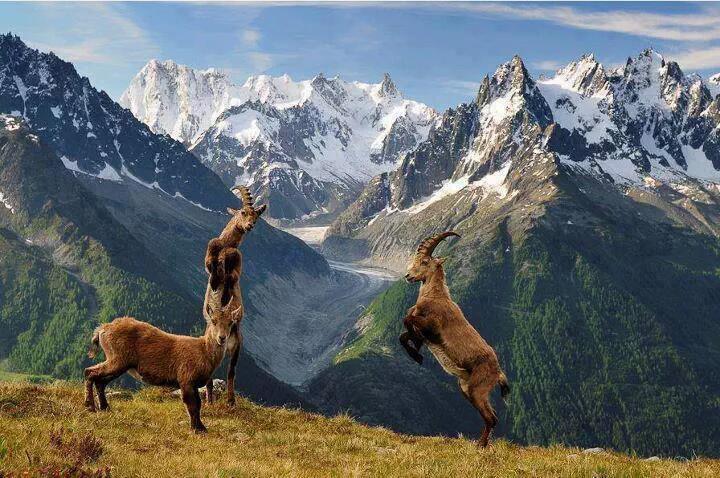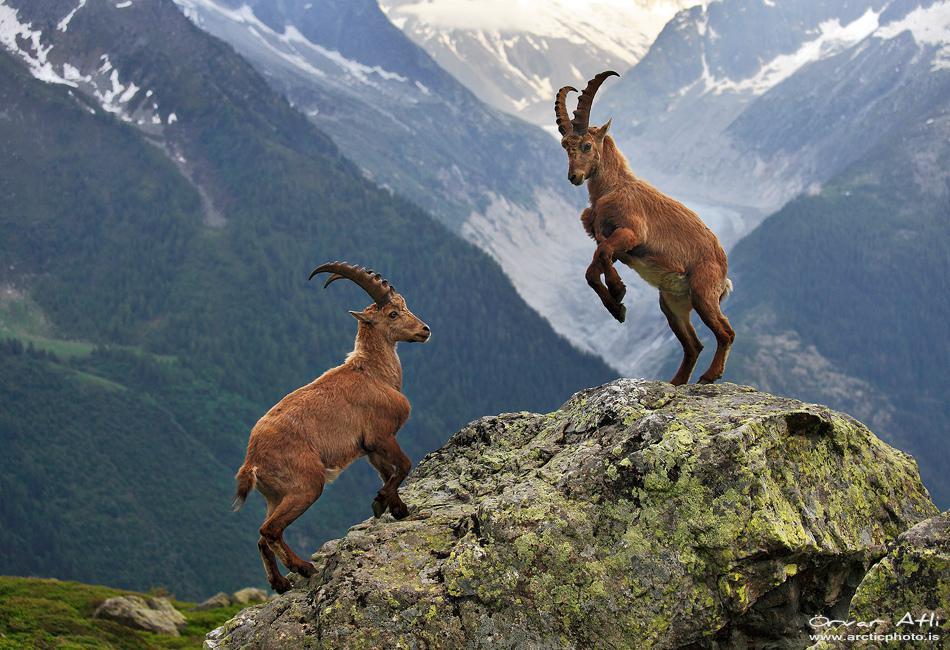The first image is the image on the left, the second image is the image on the right. Evaluate the accuracy of this statement regarding the images: "One image shows exactly one adult horned animal near at least one juvenile animal with no more than tiny horns.". Is it true? Answer yes or no. No. The first image is the image on the left, the second image is the image on the right. Assess this claim about the two images: "There are exactly four mountain goats total.". Correct or not? Answer yes or no. No. 